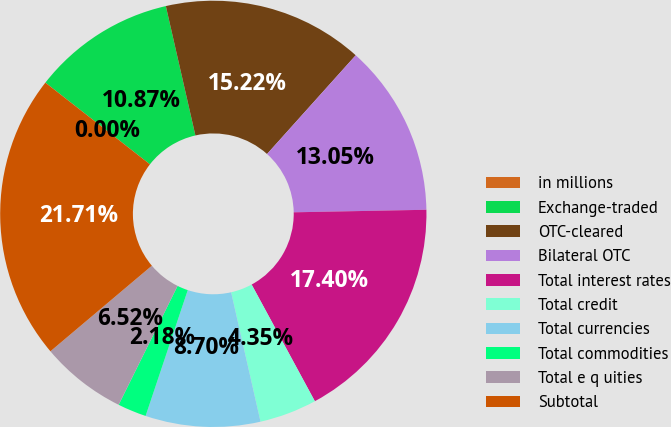Convert chart to OTSL. <chart><loc_0><loc_0><loc_500><loc_500><pie_chart><fcel>in millions<fcel>Exchange-traded<fcel>OTC-cleared<fcel>Bilateral OTC<fcel>Total interest rates<fcel>Total credit<fcel>Total currencies<fcel>Total commodities<fcel>Total e q uities<fcel>Subtotal<nl><fcel>0.0%<fcel>10.87%<fcel>15.22%<fcel>13.05%<fcel>17.4%<fcel>4.35%<fcel>8.7%<fcel>2.18%<fcel>6.52%<fcel>21.71%<nl></chart> 